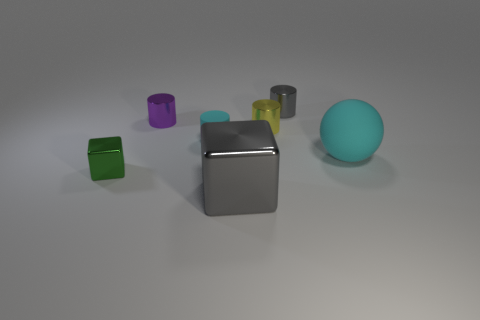Subtract 1 cylinders. How many cylinders are left? 3 Add 1 cyan matte objects. How many objects exist? 8 Subtract all cubes. How many objects are left? 5 Subtract 0 blue blocks. How many objects are left? 7 Subtract all large matte cylinders. Subtract all gray metal things. How many objects are left? 5 Add 2 cylinders. How many cylinders are left? 6 Add 1 large brown metal cubes. How many large brown metal cubes exist? 1 